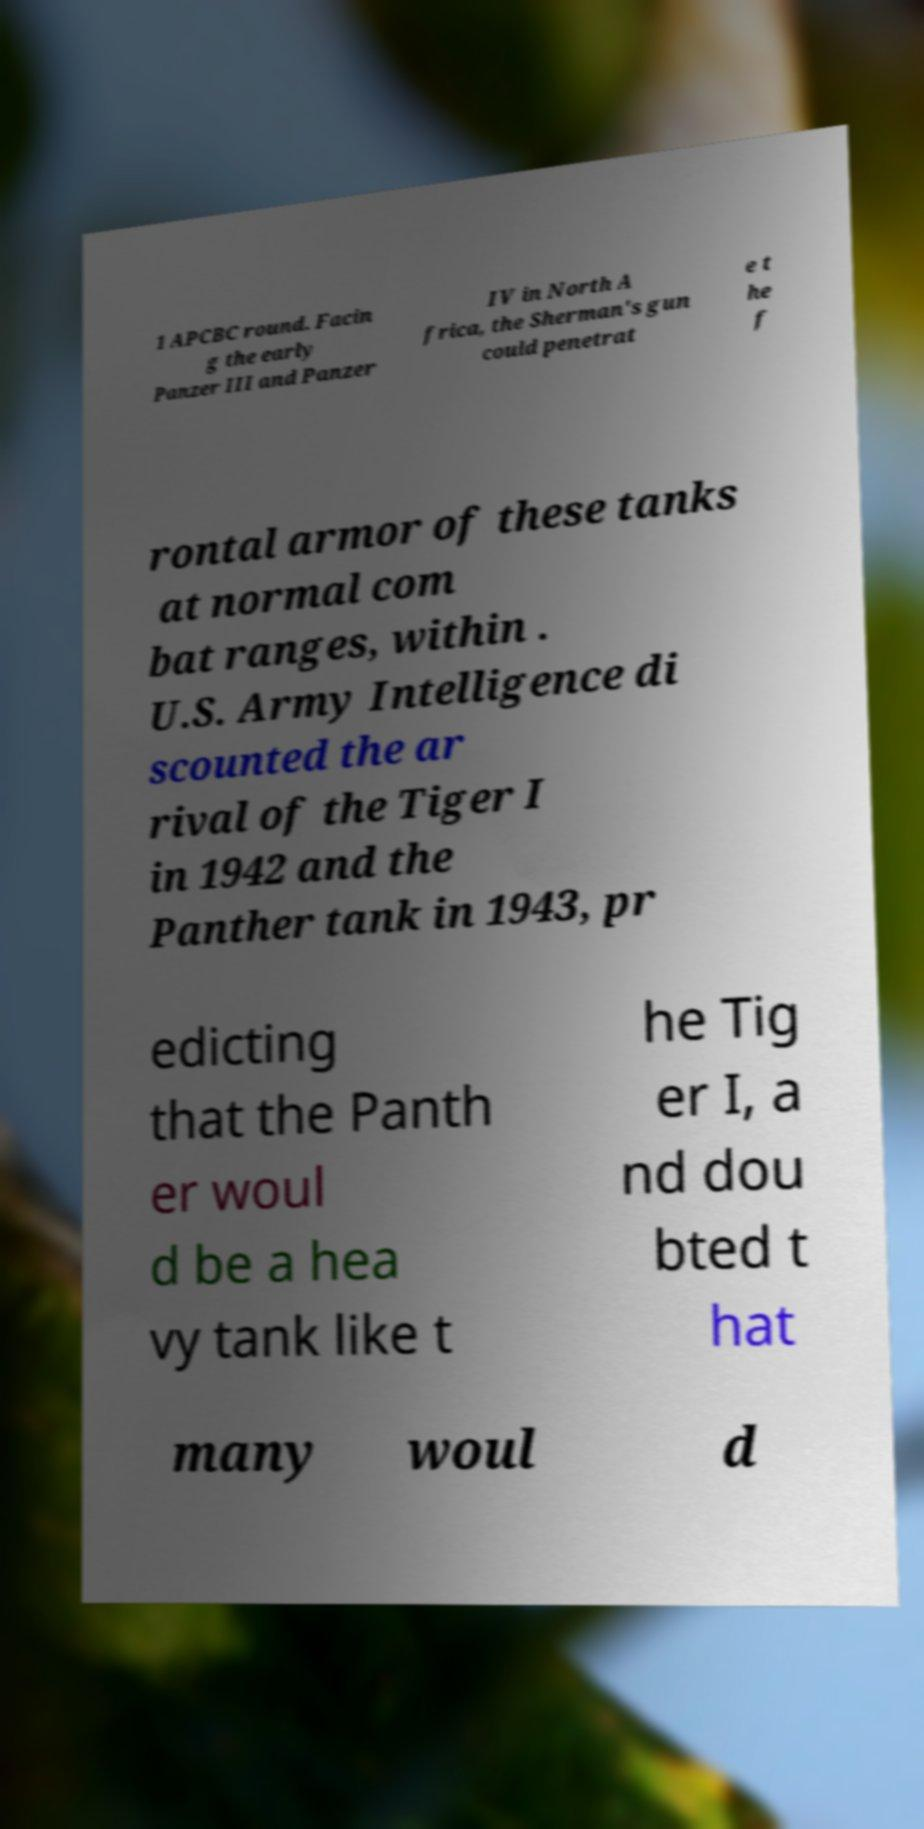I need the written content from this picture converted into text. Can you do that? 1 APCBC round. Facin g the early Panzer III and Panzer IV in North A frica, the Sherman's gun could penetrat e t he f rontal armor of these tanks at normal com bat ranges, within . U.S. Army Intelligence di scounted the ar rival of the Tiger I in 1942 and the Panther tank in 1943, pr edicting that the Panth er woul d be a hea vy tank like t he Tig er I, a nd dou bted t hat many woul d 